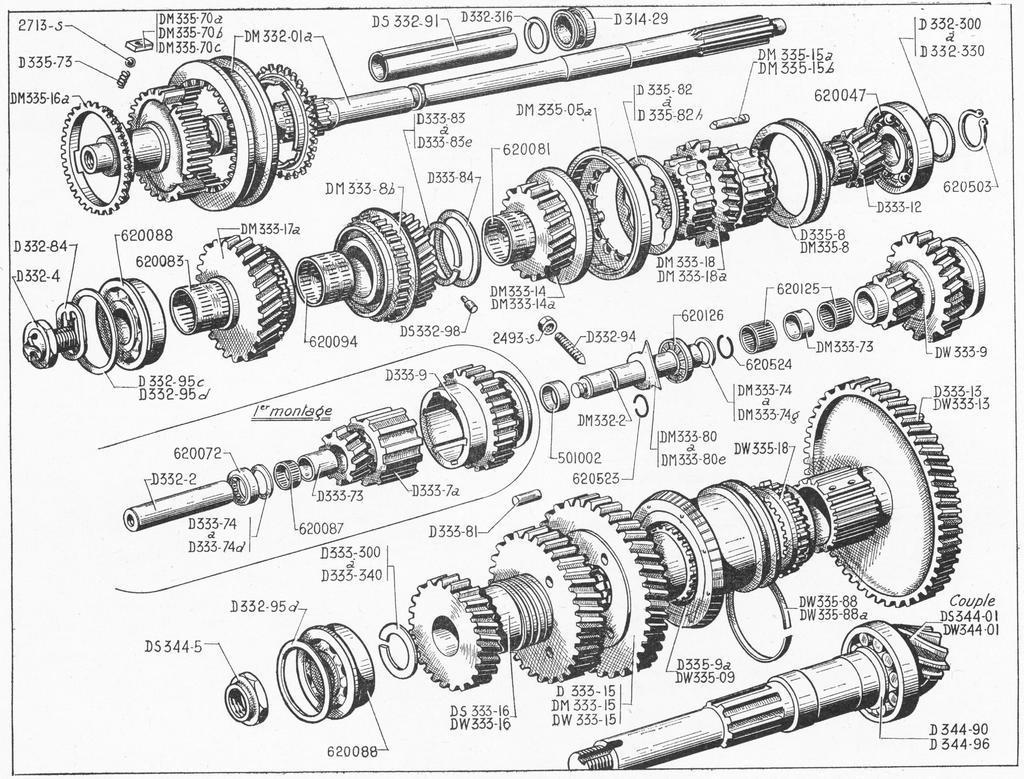In one or two sentences, can you explain what this image depicts? In this image I can see there is a sketch of machinery objects and there are numbers written on the paper. 